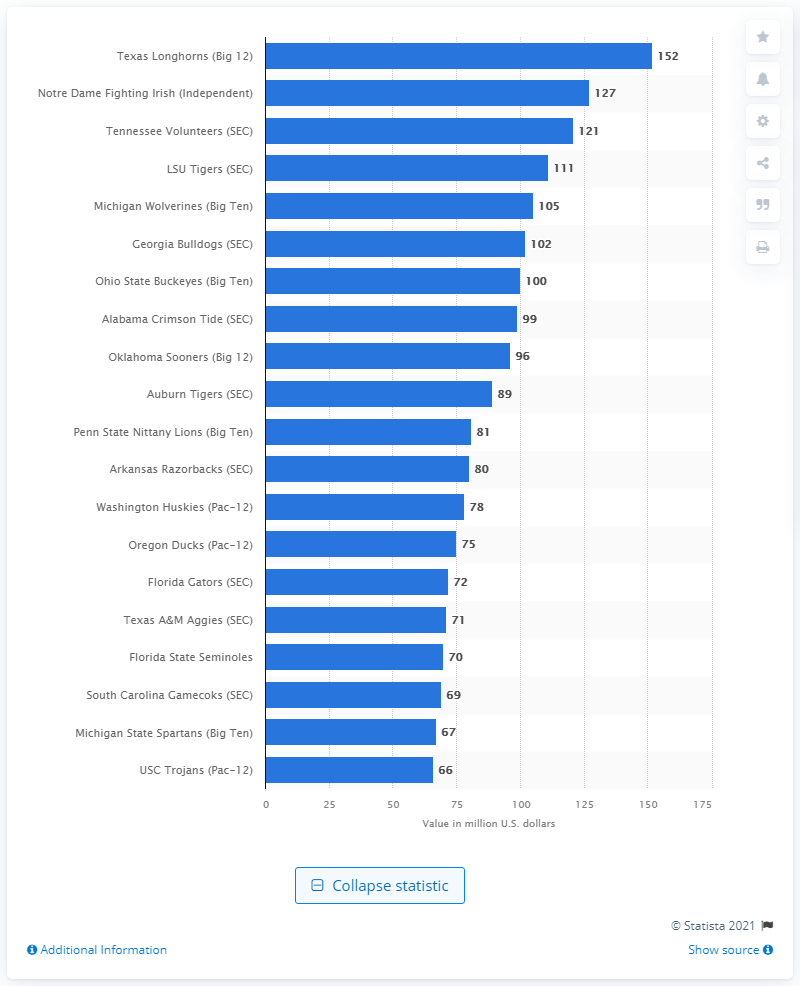Indicate a few pertinent items in this graphic. The total value of the Notre Dame Fighting Irish is approximately $127 million in dollars. 